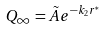<formula> <loc_0><loc_0><loc_500><loc_500>Q _ { \infty } = \tilde { A } e ^ { - k _ { 2 } r ^ { * } }</formula> 